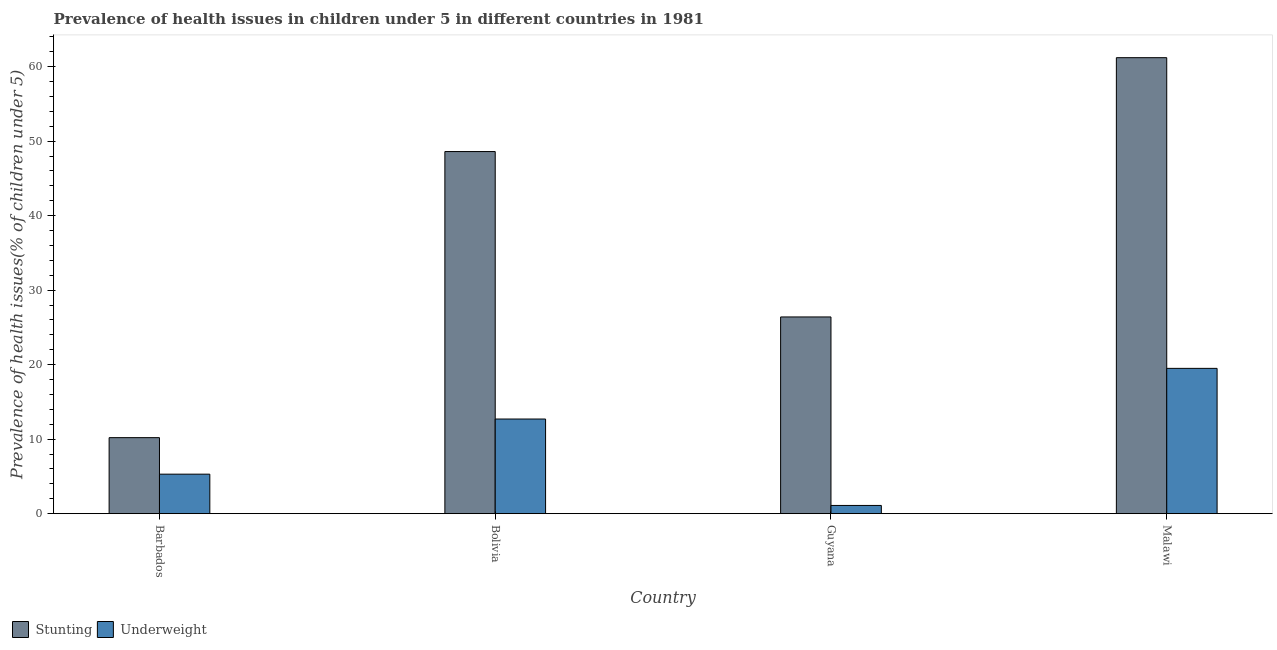How many groups of bars are there?
Ensure brevity in your answer.  4. Are the number of bars per tick equal to the number of legend labels?
Provide a short and direct response. Yes. How many bars are there on the 3rd tick from the left?
Your answer should be very brief. 2. What is the label of the 4th group of bars from the left?
Your answer should be very brief. Malawi. What is the percentage of stunted children in Guyana?
Your response must be concise. 26.4. Across all countries, what is the maximum percentage of stunted children?
Make the answer very short. 61.2. Across all countries, what is the minimum percentage of underweight children?
Your response must be concise. 1.1. In which country was the percentage of stunted children maximum?
Your response must be concise. Malawi. In which country was the percentage of stunted children minimum?
Keep it short and to the point. Barbados. What is the total percentage of underweight children in the graph?
Make the answer very short. 38.6. What is the difference between the percentage of stunted children in Guyana and that in Malawi?
Make the answer very short. -34.8. What is the difference between the percentage of underweight children in Bolivia and the percentage of stunted children in Guyana?
Your answer should be compact. -13.7. What is the average percentage of underweight children per country?
Provide a succinct answer. 9.65. What is the difference between the percentage of stunted children and percentage of underweight children in Guyana?
Offer a terse response. 25.3. What is the ratio of the percentage of stunted children in Guyana to that in Malawi?
Provide a short and direct response. 0.43. What is the difference between the highest and the second highest percentage of stunted children?
Make the answer very short. 12.6. What is the difference between the highest and the lowest percentage of stunted children?
Offer a very short reply. 51. Is the sum of the percentage of stunted children in Guyana and Malawi greater than the maximum percentage of underweight children across all countries?
Provide a short and direct response. Yes. What does the 1st bar from the left in Barbados represents?
Provide a short and direct response. Stunting. What does the 2nd bar from the right in Malawi represents?
Your answer should be very brief. Stunting. Are all the bars in the graph horizontal?
Offer a very short reply. No. Are the values on the major ticks of Y-axis written in scientific E-notation?
Give a very brief answer. No. Does the graph contain grids?
Your response must be concise. No. Where does the legend appear in the graph?
Your answer should be compact. Bottom left. How many legend labels are there?
Provide a succinct answer. 2. How are the legend labels stacked?
Make the answer very short. Horizontal. What is the title of the graph?
Keep it short and to the point. Prevalence of health issues in children under 5 in different countries in 1981. Does "Highest 10% of population" appear as one of the legend labels in the graph?
Provide a short and direct response. No. What is the label or title of the Y-axis?
Your response must be concise. Prevalence of health issues(% of children under 5). What is the Prevalence of health issues(% of children under 5) of Stunting in Barbados?
Provide a succinct answer. 10.2. What is the Prevalence of health issues(% of children under 5) of Underweight in Barbados?
Make the answer very short. 5.3. What is the Prevalence of health issues(% of children under 5) in Stunting in Bolivia?
Keep it short and to the point. 48.6. What is the Prevalence of health issues(% of children under 5) in Underweight in Bolivia?
Your answer should be compact. 12.7. What is the Prevalence of health issues(% of children under 5) of Stunting in Guyana?
Keep it short and to the point. 26.4. What is the Prevalence of health issues(% of children under 5) of Underweight in Guyana?
Ensure brevity in your answer.  1.1. What is the Prevalence of health issues(% of children under 5) of Stunting in Malawi?
Make the answer very short. 61.2. What is the Prevalence of health issues(% of children under 5) in Underweight in Malawi?
Ensure brevity in your answer.  19.5. Across all countries, what is the maximum Prevalence of health issues(% of children under 5) of Stunting?
Your response must be concise. 61.2. Across all countries, what is the minimum Prevalence of health issues(% of children under 5) in Stunting?
Offer a very short reply. 10.2. Across all countries, what is the minimum Prevalence of health issues(% of children under 5) in Underweight?
Offer a terse response. 1.1. What is the total Prevalence of health issues(% of children under 5) of Stunting in the graph?
Offer a terse response. 146.4. What is the total Prevalence of health issues(% of children under 5) in Underweight in the graph?
Offer a terse response. 38.6. What is the difference between the Prevalence of health issues(% of children under 5) in Stunting in Barbados and that in Bolivia?
Your response must be concise. -38.4. What is the difference between the Prevalence of health issues(% of children under 5) of Stunting in Barbados and that in Guyana?
Provide a succinct answer. -16.2. What is the difference between the Prevalence of health issues(% of children under 5) in Underweight in Barbados and that in Guyana?
Your response must be concise. 4.2. What is the difference between the Prevalence of health issues(% of children under 5) of Stunting in Barbados and that in Malawi?
Offer a terse response. -51. What is the difference between the Prevalence of health issues(% of children under 5) of Underweight in Barbados and that in Malawi?
Give a very brief answer. -14.2. What is the difference between the Prevalence of health issues(% of children under 5) of Underweight in Bolivia and that in Guyana?
Your response must be concise. 11.6. What is the difference between the Prevalence of health issues(% of children under 5) in Underweight in Bolivia and that in Malawi?
Offer a terse response. -6.8. What is the difference between the Prevalence of health issues(% of children under 5) in Stunting in Guyana and that in Malawi?
Keep it short and to the point. -34.8. What is the difference between the Prevalence of health issues(% of children under 5) in Underweight in Guyana and that in Malawi?
Your answer should be very brief. -18.4. What is the difference between the Prevalence of health issues(% of children under 5) of Stunting in Bolivia and the Prevalence of health issues(% of children under 5) of Underweight in Guyana?
Provide a succinct answer. 47.5. What is the difference between the Prevalence of health issues(% of children under 5) in Stunting in Bolivia and the Prevalence of health issues(% of children under 5) in Underweight in Malawi?
Make the answer very short. 29.1. What is the average Prevalence of health issues(% of children under 5) in Stunting per country?
Keep it short and to the point. 36.6. What is the average Prevalence of health issues(% of children under 5) of Underweight per country?
Your response must be concise. 9.65. What is the difference between the Prevalence of health issues(% of children under 5) of Stunting and Prevalence of health issues(% of children under 5) of Underweight in Bolivia?
Keep it short and to the point. 35.9. What is the difference between the Prevalence of health issues(% of children under 5) in Stunting and Prevalence of health issues(% of children under 5) in Underweight in Guyana?
Make the answer very short. 25.3. What is the difference between the Prevalence of health issues(% of children under 5) in Stunting and Prevalence of health issues(% of children under 5) in Underweight in Malawi?
Keep it short and to the point. 41.7. What is the ratio of the Prevalence of health issues(% of children under 5) in Stunting in Barbados to that in Bolivia?
Offer a very short reply. 0.21. What is the ratio of the Prevalence of health issues(% of children under 5) in Underweight in Barbados to that in Bolivia?
Your answer should be compact. 0.42. What is the ratio of the Prevalence of health issues(% of children under 5) of Stunting in Barbados to that in Guyana?
Your response must be concise. 0.39. What is the ratio of the Prevalence of health issues(% of children under 5) in Underweight in Barbados to that in Guyana?
Offer a terse response. 4.82. What is the ratio of the Prevalence of health issues(% of children under 5) in Stunting in Barbados to that in Malawi?
Give a very brief answer. 0.17. What is the ratio of the Prevalence of health issues(% of children under 5) of Underweight in Barbados to that in Malawi?
Offer a very short reply. 0.27. What is the ratio of the Prevalence of health issues(% of children under 5) in Stunting in Bolivia to that in Guyana?
Keep it short and to the point. 1.84. What is the ratio of the Prevalence of health issues(% of children under 5) in Underweight in Bolivia to that in Guyana?
Your answer should be compact. 11.55. What is the ratio of the Prevalence of health issues(% of children under 5) in Stunting in Bolivia to that in Malawi?
Give a very brief answer. 0.79. What is the ratio of the Prevalence of health issues(% of children under 5) of Underweight in Bolivia to that in Malawi?
Offer a very short reply. 0.65. What is the ratio of the Prevalence of health issues(% of children under 5) in Stunting in Guyana to that in Malawi?
Provide a short and direct response. 0.43. What is the ratio of the Prevalence of health issues(% of children under 5) of Underweight in Guyana to that in Malawi?
Give a very brief answer. 0.06. What is the difference between the highest and the second highest Prevalence of health issues(% of children under 5) of Stunting?
Make the answer very short. 12.6. What is the difference between the highest and the lowest Prevalence of health issues(% of children under 5) in Stunting?
Your answer should be very brief. 51. What is the difference between the highest and the lowest Prevalence of health issues(% of children under 5) of Underweight?
Provide a succinct answer. 18.4. 